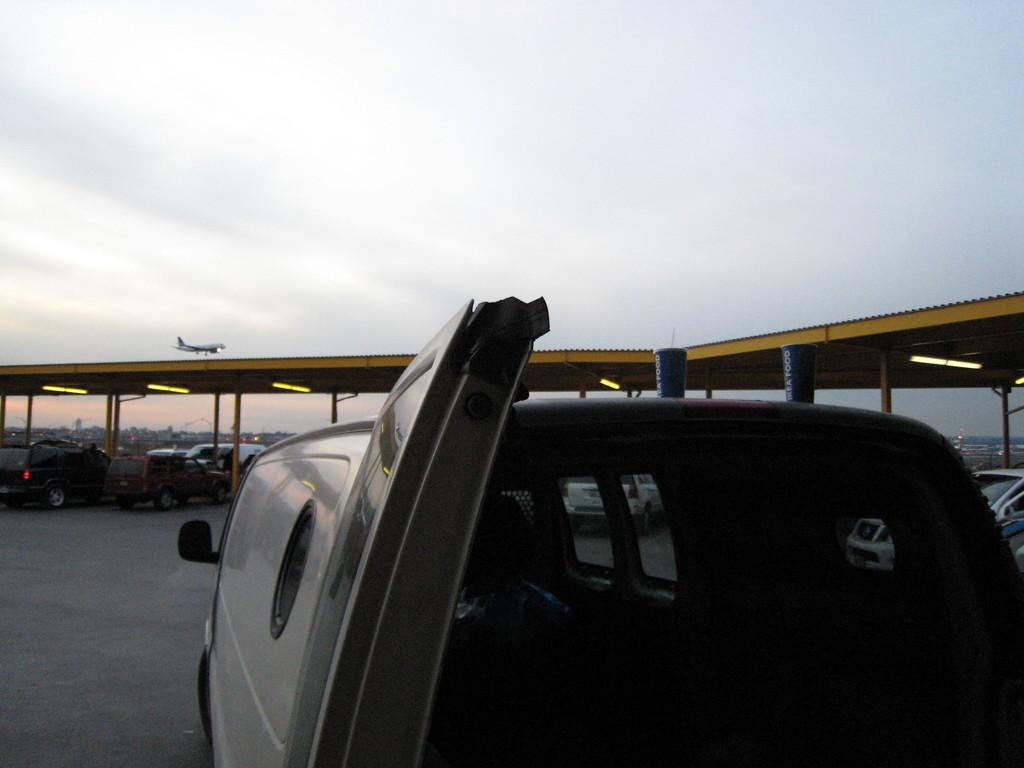What can be seen on the road in the image? There are vehicles on the road in the image. What object is present in the image that is not a vehicle or a building? There is a pole in the image. What type of structure can be seen in the image? There is a shed in the image. What is on the roof of the shed in the image? There are lights on the roof in the image. What is visible in the sky in the image? There is an airplane visible in the sky in the image. How many cherries are hanging from the van in the image? There is no van or cherries present in the image. Is it raining in the image? There is no indication of rain in the image. 